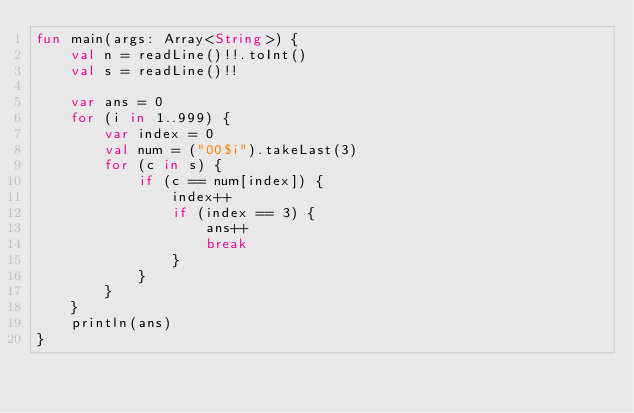<code> <loc_0><loc_0><loc_500><loc_500><_Kotlin_>fun main(args: Array<String>) {
    val n = readLine()!!.toInt()
    val s = readLine()!!

    var ans = 0
    for (i in 1..999) {
        var index = 0
        val num = ("00$i").takeLast(3)
        for (c in s) {
            if (c == num[index]) {
                index++
                if (index == 3) {
                    ans++
                    break
                }
            }
        }
    }
    println(ans)
}</code> 